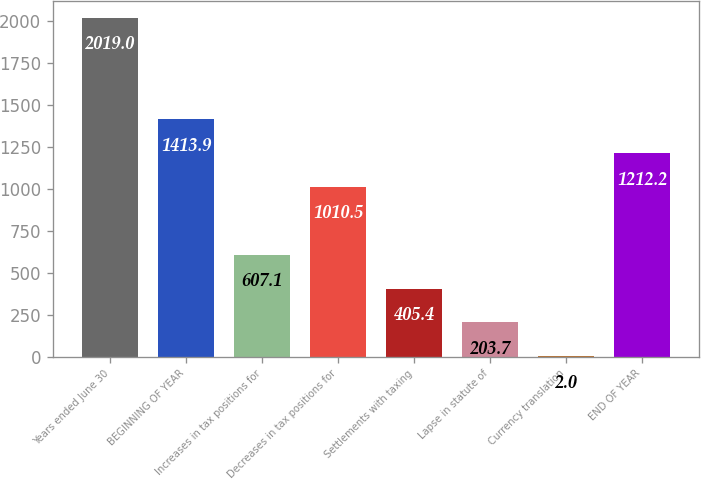Convert chart. <chart><loc_0><loc_0><loc_500><loc_500><bar_chart><fcel>Years ended June 30<fcel>BEGINNING OF YEAR<fcel>Increases in tax positions for<fcel>Decreases in tax positions for<fcel>Settlements with taxing<fcel>Lapse in statute of<fcel>Currency translation<fcel>END OF YEAR<nl><fcel>2019<fcel>1413.9<fcel>607.1<fcel>1010.5<fcel>405.4<fcel>203.7<fcel>2<fcel>1212.2<nl></chart> 